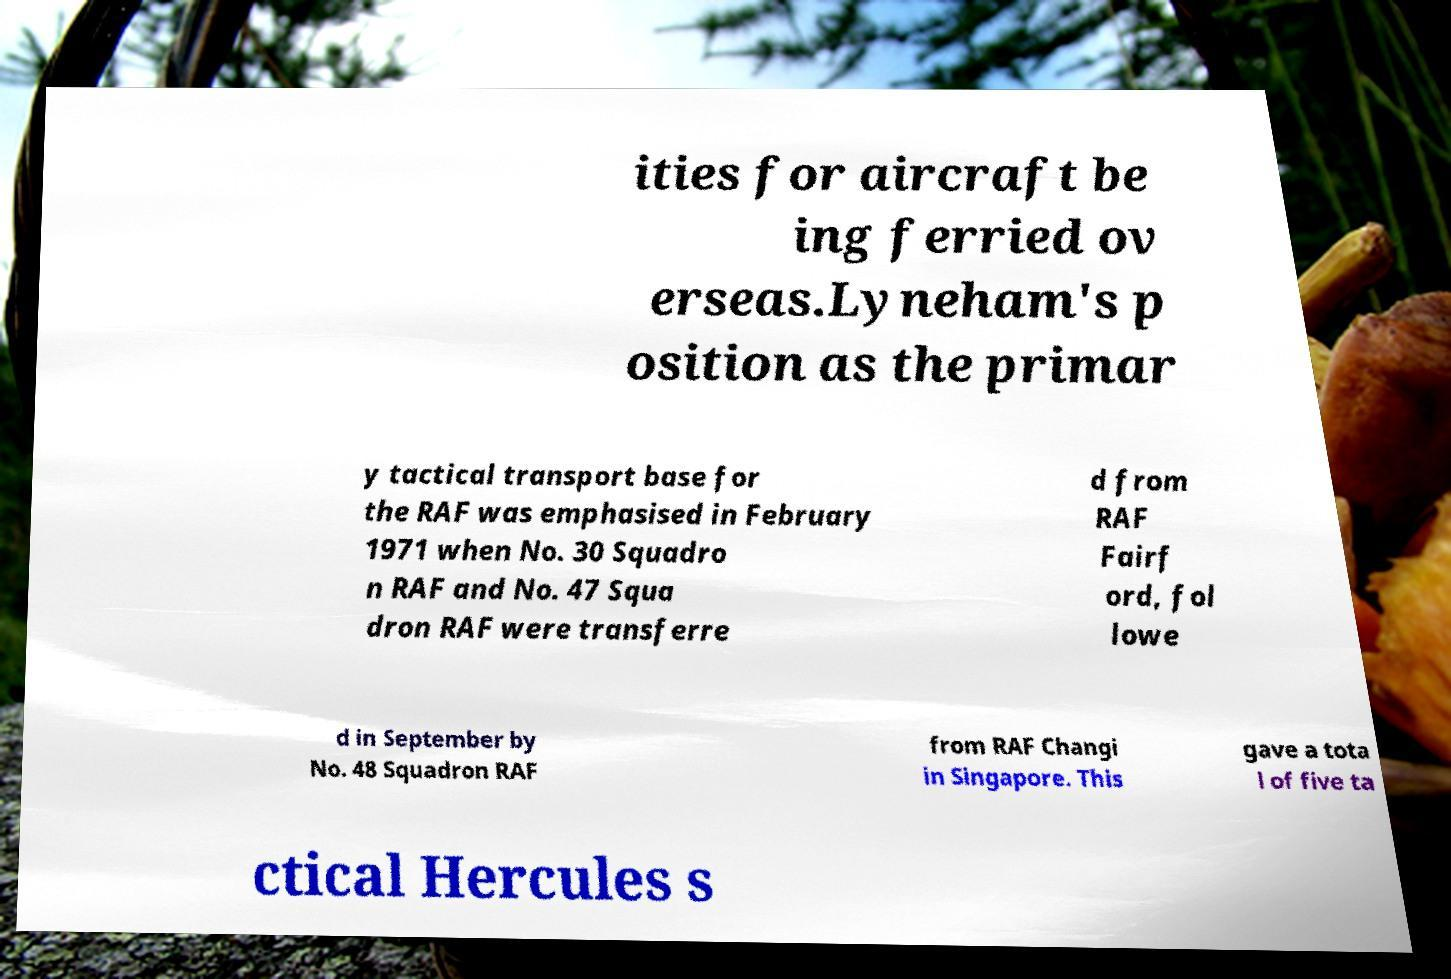Please identify and transcribe the text found in this image. ities for aircraft be ing ferried ov erseas.Lyneham's p osition as the primar y tactical transport base for the RAF was emphasised in February 1971 when No. 30 Squadro n RAF and No. 47 Squa dron RAF were transferre d from RAF Fairf ord, fol lowe d in September by No. 48 Squadron RAF from RAF Changi in Singapore. This gave a tota l of five ta ctical Hercules s 